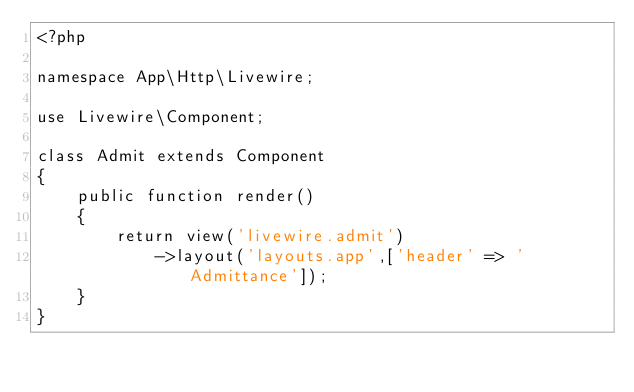Convert code to text. <code><loc_0><loc_0><loc_500><loc_500><_PHP_><?php

namespace App\Http\Livewire;

use Livewire\Component;

class Admit extends Component
{
    public function render()
    {
        return view('livewire.admit')
            ->layout('layouts.app',['header' => 'Admittance']);
    }
}
</code> 